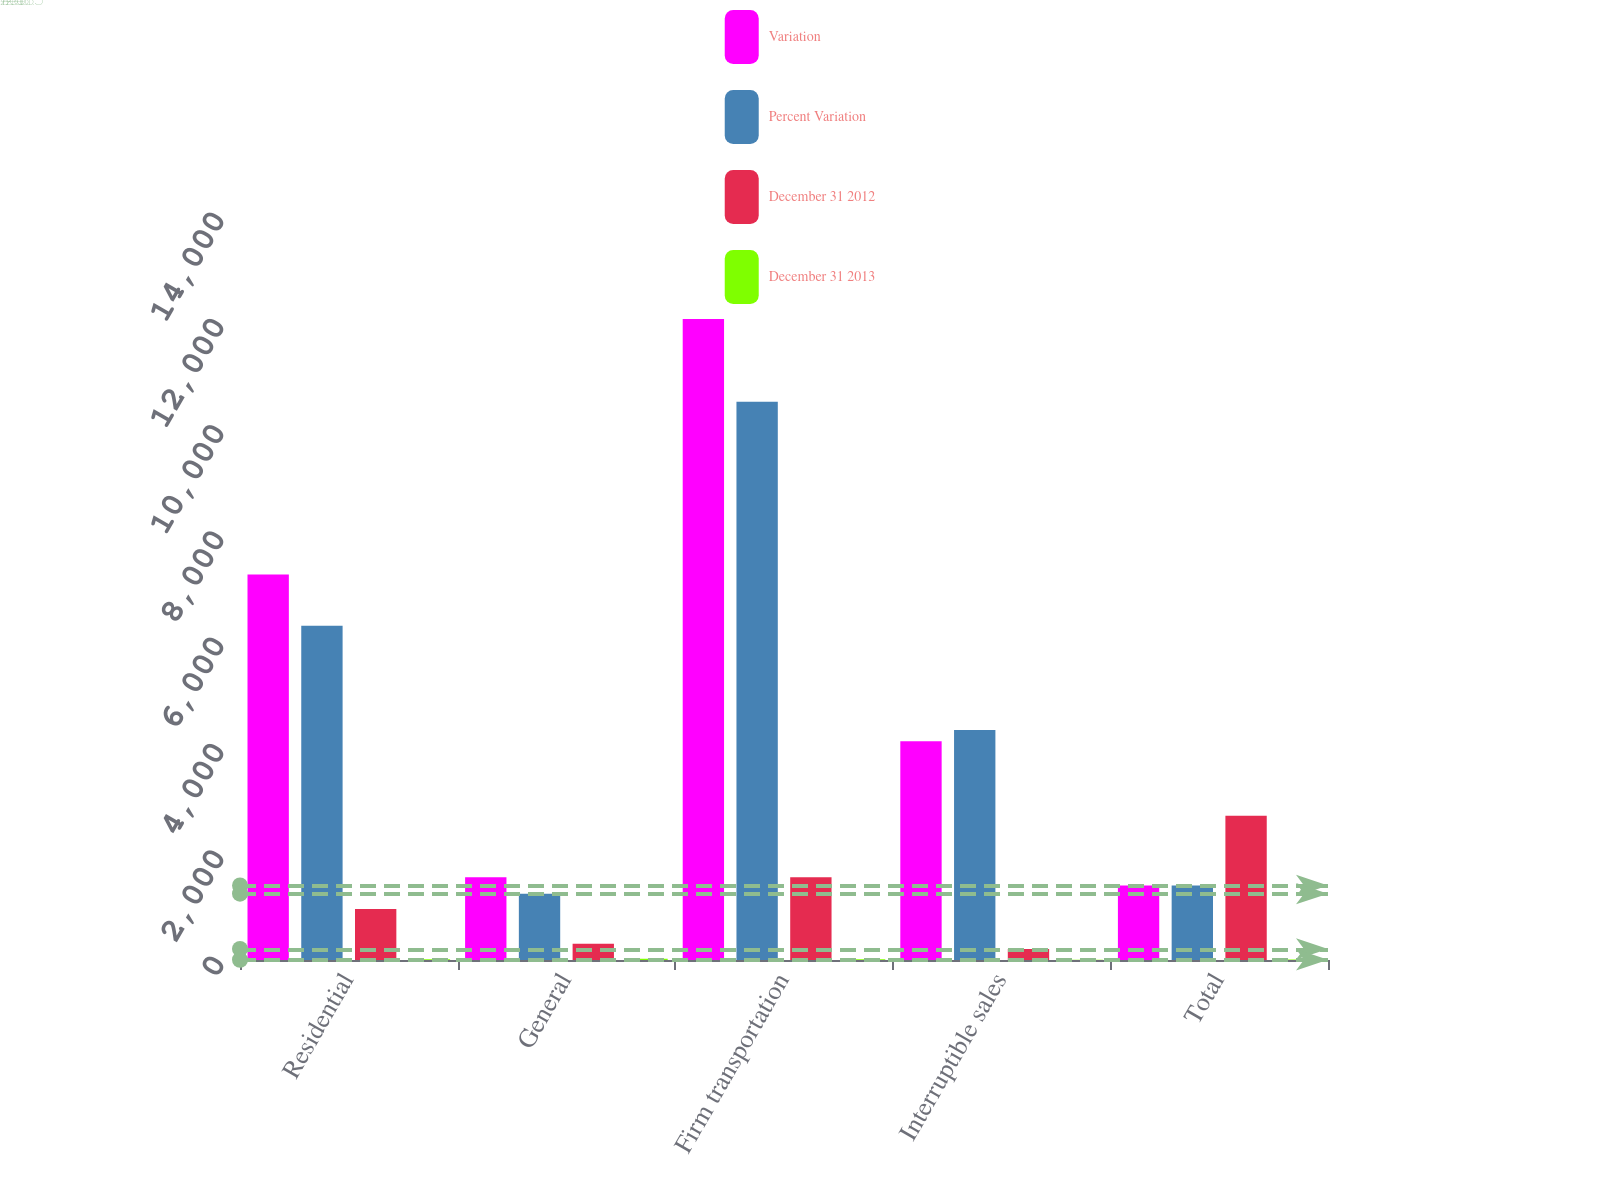Convert chart to OTSL. <chart><loc_0><loc_0><loc_500><loc_500><stacked_bar_chart><ecel><fcel>Residential<fcel>General<fcel>Firm transportation<fcel>Interruptible sales<fcel>Total<nl><fcel>Variation<fcel>7253<fcel>1555<fcel>12062<fcel>4118<fcel>1401.5<nl><fcel>Percent Variation<fcel>6291<fcel>1248<fcel>10505<fcel>4326<fcel>1401.5<nl><fcel>December 31 2012<fcel>962<fcel>307<fcel>1557<fcel>208<fcel>2714<nl><fcel>December 31 2013<fcel>15.3<fcel>24.6<fcel>14.8<fcel>4.8<fcel>11.7<nl></chart> 